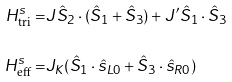<formula> <loc_0><loc_0><loc_500><loc_500>H _ { \text {tri} } ^ { s } = & J \hat { S } _ { 2 } \cdot ( \hat { S } _ { 1 } + \hat { S } _ { 3 } ) + J ^ { \prime } \hat { S } _ { 1 } \cdot \hat { S } _ { 3 } \\ H _ { \text {eff} } ^ { s } = & J _ { K } ( \hat { S } _ { 1 } \cdot \hat { s } _ { L 0 } + \hat { S } _ { 3 } \cdot \hat { s } _ { R 0 } )</formula> 